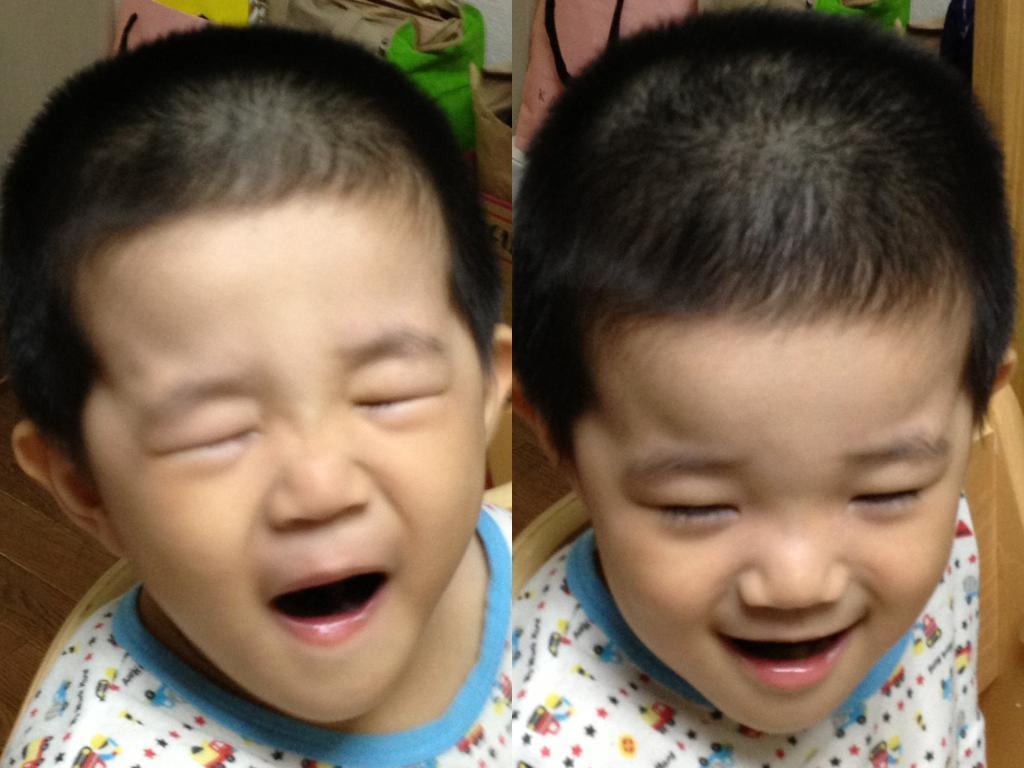Could you give a brief overview of what you see in this image? In this picture we can see collage of two images, in these pictures we can see a kid is sitting on a chair. 